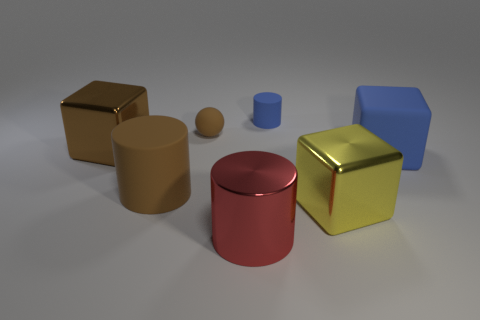Is the color of the matte ball the same as the small rubber cylinder?
Your answer should be very brief. No. There is a large cube in front of the brown rubber object that is in front of the brown matte sphere; what is its material?
Give a very brief answer. Metal. There is a brown object that is the same shape as the large blue rubber thing; what is its material?
Give a very brief answer. Metal. Are there any balls on the right side of the small blue matte cylinder to the right of the large brown metal cube that is to the left of the red thing?
Provide a short and direct response. No. How many other objects are the same color as the sphere?
Keep it short and to the point. 2. How many objects are to the left of the large red metallic thing and in front of the large rubber block?
Provide a succinct answer. 1. The small blue rubber object is what shape?
Provide a short and direct response. Cylinder. What number of other things are there of the same material as the large brown cube
Offer a very short reply. 2. What is the color of the big metallic block in front of the metal thing that is on the left side of the brown thing that is in front of the large blue matte thing?
Your answer should be very brief. Yellow. What material is the yellow thing that is the same size as the rubber cube?
Keep it short and to the point. Metal. 